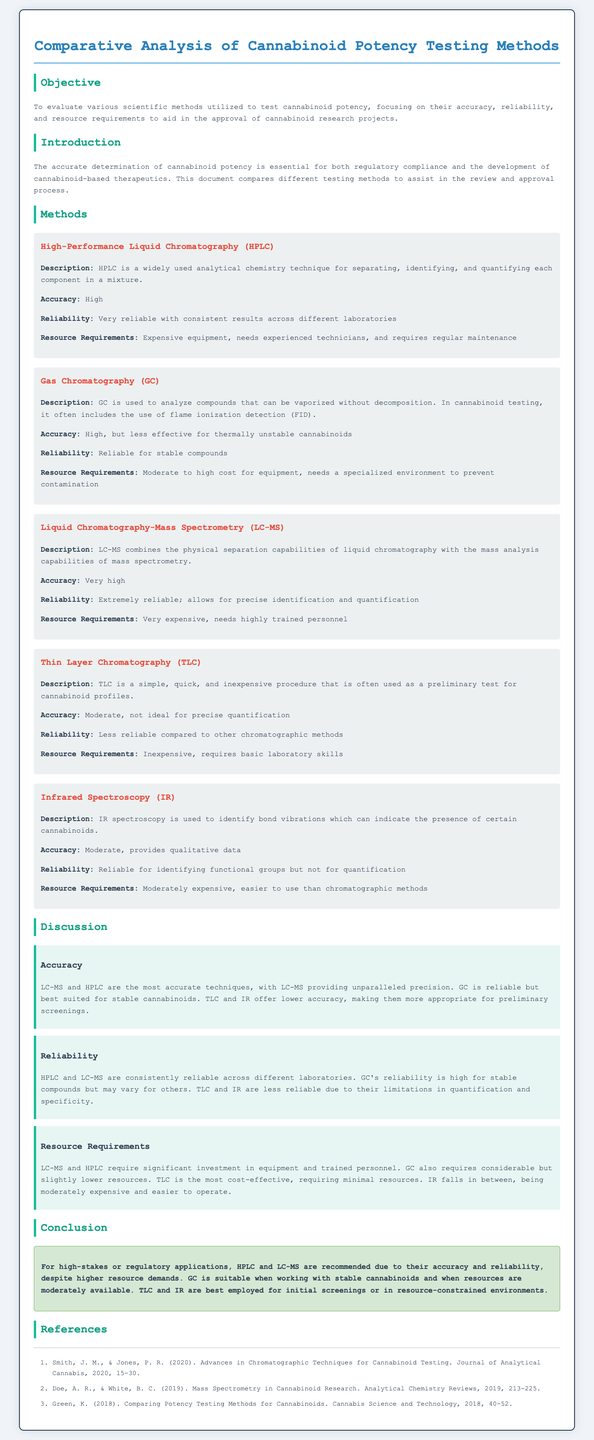What is the objective of the document? The objective is to evaluate various scientific methods utilized to test cannabinoid potency, focusing on their accuracy, reliability, and resource requirements.
Answer: To evaluate various scientific methods What is the accuracy level of HPLC? The accuracy of HPLC is mentioned in the document as high.
Answer: High Which method has the highest reliability? The document states that LC-MS is extremely reliable and allows for precise identification and quantification.
Answer: LC-MS What are the resource requirements for Thin Layer Chromatography? The resource requirements for TLC are described as inexpensive, and it requires basic laboratory skills.
Answer: Inexpensive, basic laboratory skills Which method is recommended for high-stakes or regulatory applications? The conclusion of the document recommends HPLC and LC-MS for high-stakes or regulatory applications due to their accuracy and reliability.
Answer: HPLC and LC-MS What is the main limitation of Infrared Spectroscopy? The document notes that IR is reliable for identifying functional groups but not for quantification, indicating its main limitation.
Answer: Not for quantification How many references are listed in the document? The document lists three references at the end.
Answer: Three What is the description of Gas Chromatography? The description states that GC is used to analyze compounds that can be vaporized without decomposition and often includes flame ionization detection.
Answer: Analyzes compounds that can be vaporized without decomposition 